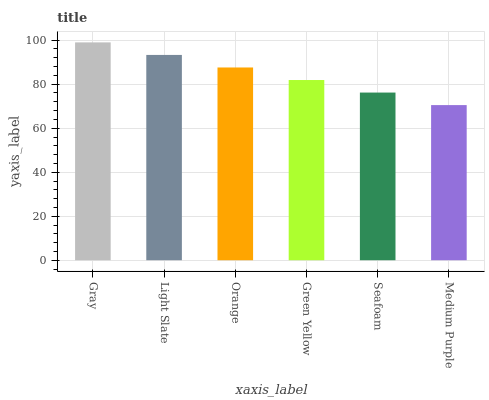Is Medium Purple the minimum?
Answer yes or no. Yes. Is Gray the maximum?
Answer yes or no. Yes. Is Light Slate the minimum?
Answer yes or no. No. Is Light Slate the maximum?
Answer yes or no. No. Is Gray greater than Light Slate?
Answer yes or no. Yes. Is Light Slate less than Gray?
Answer yes or no. Yes. Is Light Slate greater than Gray?
Answer yes or no. No. Is Gray less than Light Slate?
Answer yes or no. No. Is Orange the high median?
Answer yes or no. Yes. Is Green Yellow the low median?
Answer yes or no. Yes. Is Green Yellow the high median?
Answer yes or no. No. Is Medium Purple the low median?
Answer yes or no. No. 